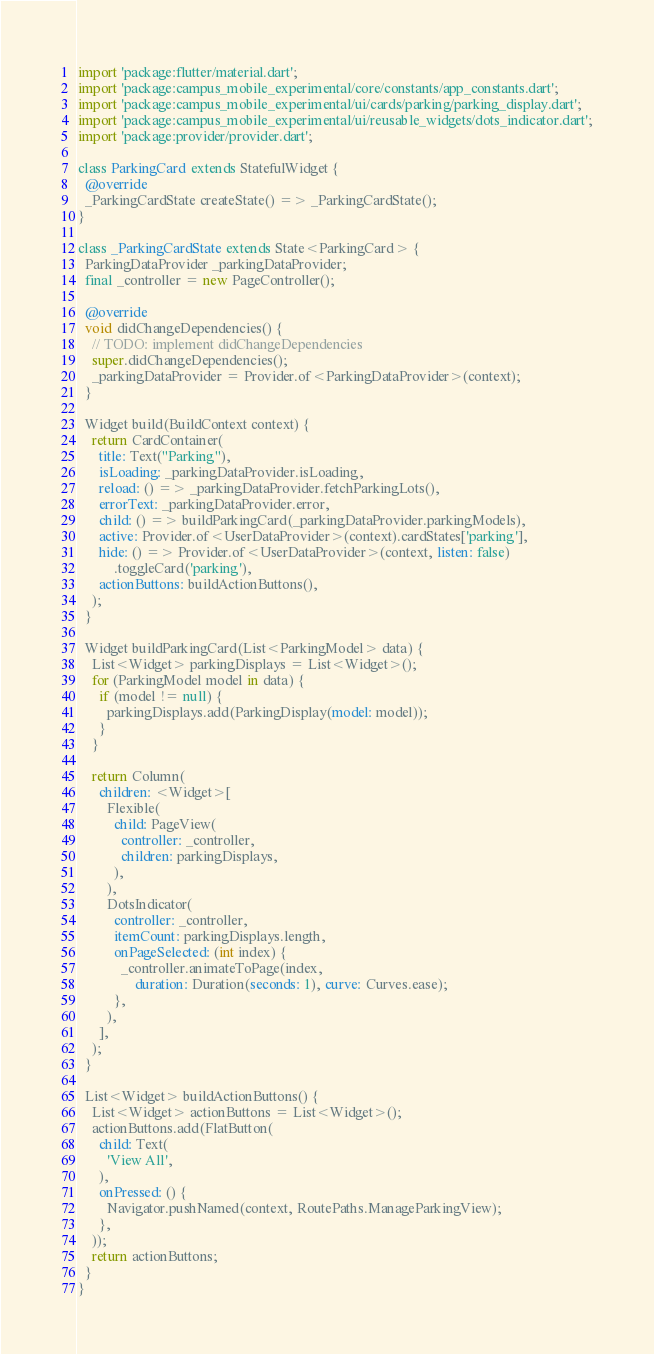<code> <loc_0><loc_0><loc_500><loc_500><_Dart_>import 'package:flutter/material.dart';
import 'package:campus_mobile_experimental/core/constants/app_constants.dart';
import 'package:campus_mobile_experimental/ui/cards/parking/parking_display.dart';
import 'package:campus_mobile_experimental/ui/reusable_widgets/dots_indicator.dart';
import 'package:provider/provider.dart';

class ParkingCard extends StatefulWidget {
  @override
  _ParkingCardState createState() => _ParkingCardState();
}

class _ParkingCardState extends State<ParkingCard> {
  ParkingDataProvider _parkingDataProvider;
  final _controller = new PageController();

  @override
  void didChangeDependencies() {
    // TODO: implement didChangeDependencies
    super.didChangeDependencies();
    _parkingDataProvider = Provider.of<ParkingDataProvider>(context);
  }

  Widget build(BuildContext context) {
    return CardContainer(
      title: Text("Parking"),
      isLoading: _parkingDataProvider.isLoading,
      reload: () => _parkingDataProvider.fetchParkingLots(),
      errorText: _parkingDataProvider.error,
      child: () => buildParkingCard(_parkingDataProvider.parkingModels),
      active: Provider.of<UserDataProvider>(context).cardStates['parking'],
      hide: () => Provider.of<UserDataProvider>(context, listen: false)
          .toggleCard('parking'),
      actionButtons: buildActionButtons(),
    );
  }

  Widget buildParkingCard(List<ParkingModel> data) {
    List<Widget> parkingDisplays = List<Widget>();
    for (ParkingModel model in data) {
      if (model != null) {
        parkingDisplays.add(ParkingDisplay(model: model));
      }
    }

    return Column(
      children: <Widget>[
        Flexible(
          child: PageView(
            controller: _controller,
            children: parkingDisplays,
          ),
        ),
        DotsIndicator(
          controller: _controller,
          itemCount: parkingDisplays.length,
          onPageSelected: (int index) {
            _controller.animateToPage(index,
                duration: Duration(seconds: 1), curve: Curves.ease);
          },
        ),
      ],
    );
  }

  List<Widget> buildActionButtons() {
    List<Widget> actionButtons = List<Widget>();
    actionButtons.add(FlatButton(
      child: Text(
        'View All',
      ),
      onPressed: () {
        Navigator.pushNamed(context, RoutePaths.ManageParkingView);
      },
    ));
    return actionButtons;
  }
}
</code> 